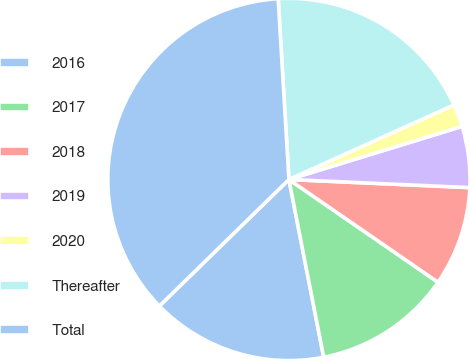Convert chart. <chart><loc_0><loc_0><loc_500><loc_500><pie_chart><fcel>2016<fcel>2017<fcel>2018<fcel>2019<fcel>2020<fcel>Thereafter<fcel>Total<nl><fcel>15.76%<fcel>12.32%<fcel>8.89%<fcel>5.45%<fcel>2.02%<fcel>19.19%<fcel>36.37%<nl></chart> 